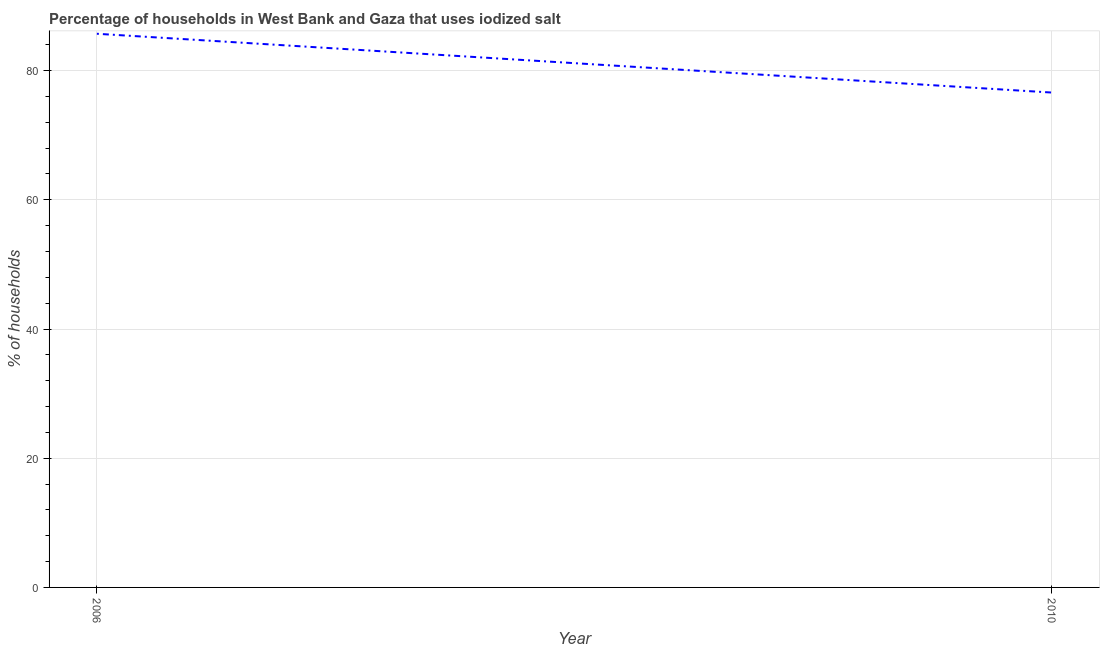What is the percentage of households where iodized salt is consumed in 2010?
Keep it short and to the point. 76.6. Across all years, what is the maximum percentage of households where iodized salt is consumed?
Offer a very short reply. 85.7. Across all years, what is the minimum percentage of households where iodized salt is consumed?
Keep it short and to the point. 76.6. In which year was the percentage of households where iodized salt is consumed maximum?
Keep it short and to the point. 2006. In which year was the percentage of households where iodized salt is consumed minimum?
Ensure brevity in your answer.  2010. What is the sum of the percentage of households where iodized salt is consumed?
Offer a terse response. 162.3. What is the difference between the percentage of households where iodized salt is consumed in 2006 and 2010?
Give a very brief answer. 9.1. What is the average percentage of households where iodized salt is consumed per year?
Offer a very short reply. 81.15. What is the median percentage of households where iodized salt is consumed?
Your answer should be compact. 81.15. In how many years, is the percentage of households where iodized salt is consumed greater than 80 %?
Your answer should be compact. 1. What is the ratio of the percentage of households where iodized salt is consumed in 2006 to that in 2010?
Offer a very short reply. 1.12. In how many years, is the percentage of households where iodized salt is consumed greater than the average percentage of households where iodized salt is consumed taken over all years?
Offer a very short reply. 1. Does the percentage of households where iodized salt is consumed monotonically increase over the years?
Offer a very short reply. No. How many years are there in the graph?
Offer a terse response. 2. Does the graph contain any zero values?
Your answer should be compact. No. Does the graph contain grids?
Your answer should be very brief. Yes. What is the title of the graph?
Keep it short and to the point. Percentage of households in West Bank and Gaza that uses iodized salt. What is the label or title of the X-axis?
Make the answer very short. Year. What is the label or title of the Y-axis?
Make the answer very short. % of households. What is the % of households of 2006?
Provide a short and direct response. 85.7. What is the % of households of 2010?
Provide a succinct answer. 76.6. What is the ratio of the % of households in 2006 to that in 2010?
Make the answer very short. 1.12. 